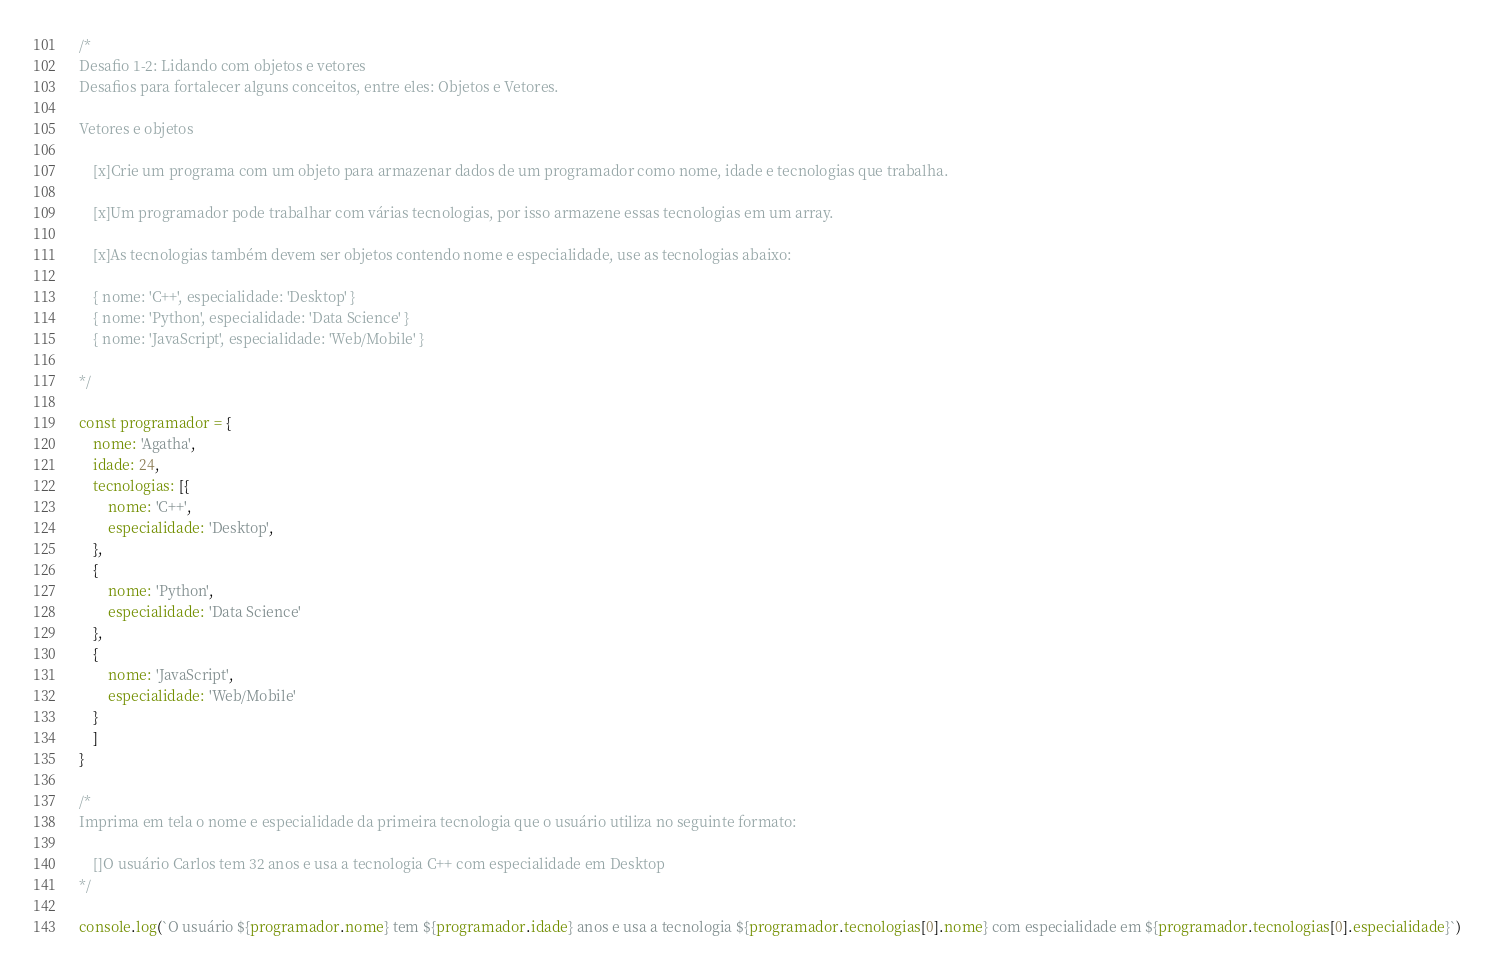<code> <loc_0><loc_0><loc_500><loc_500><_JavaScript_>/*
Desafio 1-2: Lidando com objetos e vetores
Desafios para fortalecer alguns conceitos, entre eles: Objetos e Vetores.

Vetores e objetos
    
    [x]Crie um programa com um objeto para armazenar dados de um programador como nome, idade e tecnologias que trabalha.

    [x]Um programador pode trabalhar com várias tecnologias, por isso armazene essas tecnologias em um array.

    [x]As tecnologias também devem ser objetos contendo nome e especialidade, use as tecnologias abaixo:

    { nome: 'C++', especialidade: 'Desktop' }
    { nome: 'Python', especialidade: 'Data Science' }
    { nome: 'JavaScript', especialidade: 'Web/Mobile' }

*/

const programador = {
    nome: 'Agatha',
    idade: 24,
    tecnologias: [{
        nome: 'C++',
        especialidade: 'Desktop',
    },
    {
        nome: 'Python',
        especialidade: 'Data Science'
    },
    {
        nome: 'JavaScript',
        especialidade: 'Web/Mobile'
    }
    ]
}

/*
Imprima em tela o nome e especialidade da primeira tecnologia que o usuário utiliza no seguinte formato:

    []O usuário Carlos tem 32 anos e usa a tecnologia C++ com especialidade em Desktop
*/

console.log(`O usuário ${programador.nome} tem ${programador.idade} anos e usa a tecnologia ${programador.tecnologias[0].nome} com especialidade em ${programador.tecnologias[0].especialidade}`)
</code> 